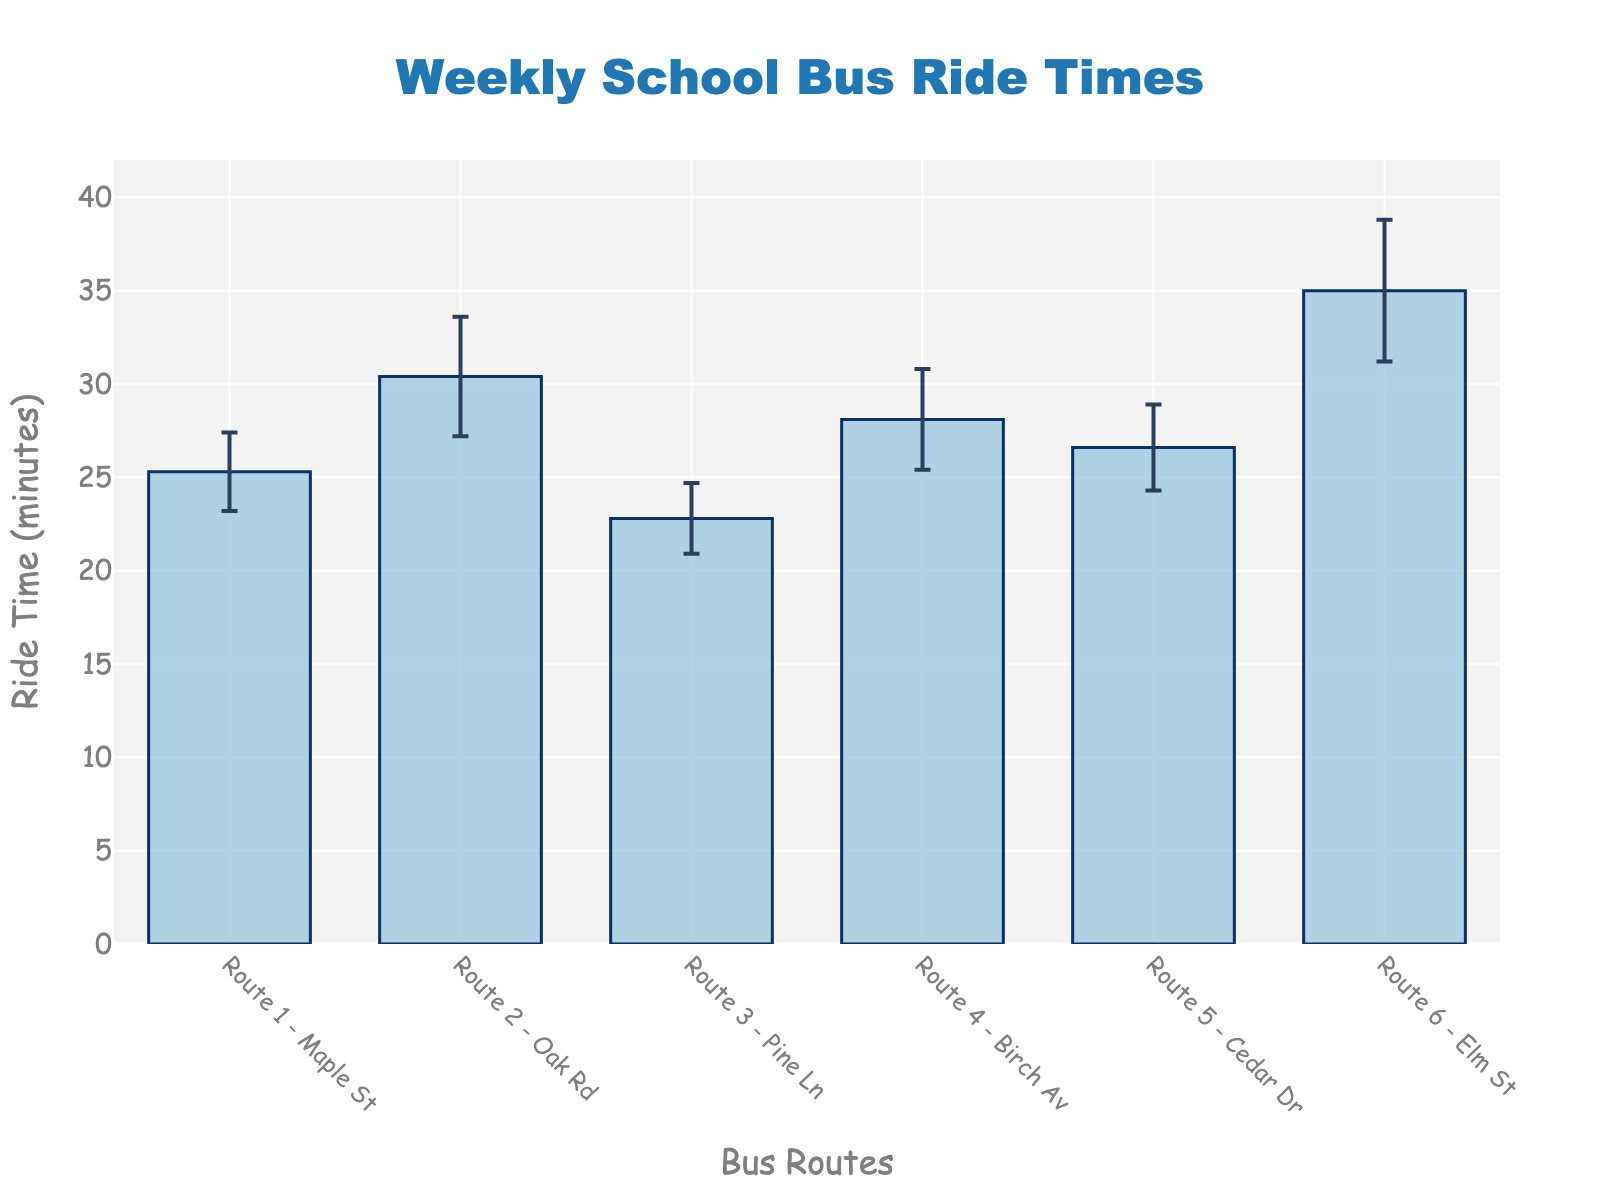What is the title of the figure? The title is prominently displayed at the top of the figure, usually in a larger, more noticeable font.
Answer: Weekly School Bus Ride Times What are the ride times for Route 3 - Pine Ln and Route 5 - Cedar Dr? Look at the height of the bars corresponding to Route 3 and Route 5. The ride time for Route 3 is shown as 22.8 minutes and for Route 5, it is 26.6 minutes.
Answer: 22.8 minutes (Route 3), 26.6 minutes (Route 5) Which route has the highest mean ride time? Identify the bar that reaches the highest point on the graph. Route 6 - Elm St has the highest bar.
Answer: Route 6 - Elm St What is the difference in mean ride time between Route 2 - Oak Rd and Route 4 - Birch Av? Subtract the ride time of Route 4 (28.1 minutes) from that of Route 2 (30.4 minutes).
Answer: 2.3 minutes Which route has the smallest standard deviation? Look at the error bars on each bar; the shortest error bar indicates the smallest standard deviation. Route 3 - Pine Ln has the smallest error bar of 1.9 minutes.
Answer: Route 3 - Pine Ln What is the average mean ride time for all routes? Add up all the mean ride times and divide by the number of routes. \((25.3 + 30.4 + 22.8 + 28.1 + 26.6 + 35.0)/6\).
Answer: 28 minutes Which two routes have the shortest and longest mean ride times respectively? Compare the heights of all bars. Route 3 - Pine Ln has the shortest, and Route 6 - Elm St has the longest.
Answer: Route 3 - Pine Ln (shortest), Route 6 - Elm St (longest) What is the range of ride times (i.e., the difference between the highest and lowest mean ride times)? Subtract the smallest mean ride time (22.8 minutes for Route 3) from the largest mean ride time (35.0 minutes for Route 6).
Answer: 12.2 minutes What color are the bars representing the mean ride times? Describe the color of the bars as seen in the figure.
Answer: Light blue What's the average value of the standard deviations across all routes? Sum all the standard deviations and divide by the number of routes. \((2.1 + 3.2 + 1.9 + 2.7 + 2.3 + 3.8)/6\).
Answer: 2.67 